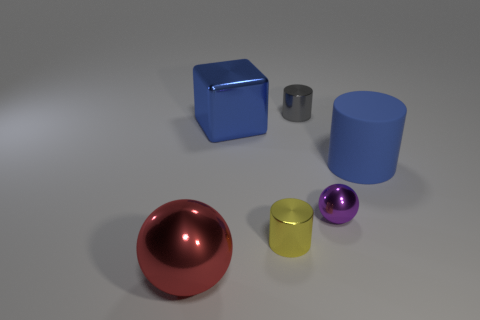Is there anything else that is the same material as the big cylinder?
Offer a very short reply. No. Are the small yellow thing and the tiny cylinder behind the large blue rubber cylinder made of the same material?
Provide a succinct answer. Yes. Does the large blue matte object have the same shape as the yellow shiny object?
Offer a very short reply. Yes. What is the material of the large thing that is the same shape as the small gray thing?
Offer a terse response. Rubber. What is the color of the tiny metal object that is left of the tiny purple object and in front of the tiny gray metal object?
Your answer should be very brief. Yellow. The big cylinder has what color?
Your answer should be compact. Blue. What is the material of the thing that is the same color as the cube?
Offer a terse response. Rubber. Are there any small yellow metal things of the same shape as the small gray metal object?
Make the answer very short. Yes. There is a metal object on the left side of the big metallic block; what size is it?
Provide a short and direct response. Large. There is a blue cylinder that is the same size as the cube; what is it made of?
Offer a terse response. Rubber. 